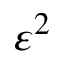<formula> <loc_0><loc_0><loc_500><loc_500>\varepsilon ^ { 2 }</formula> 